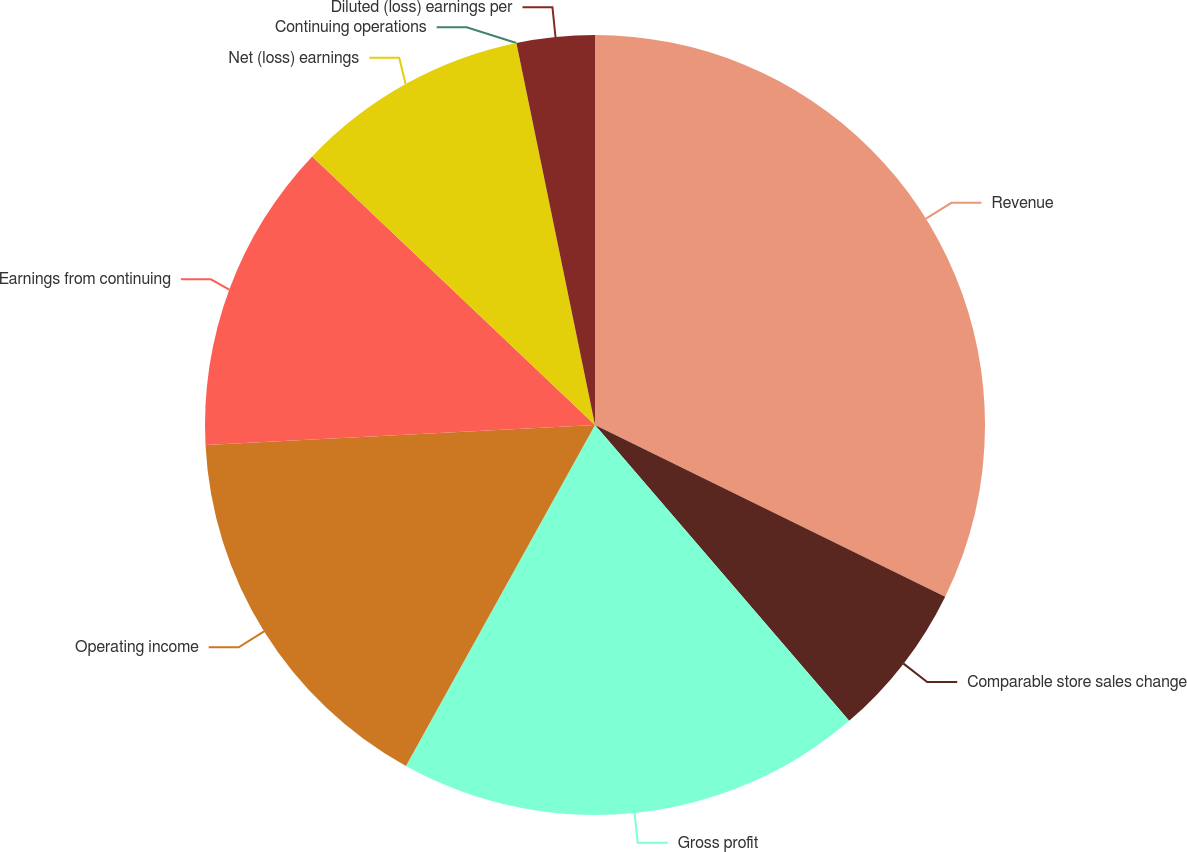Convert chart. <chart><loc_0><loc_0><loc_500><loc_500><pie_chart><fcel>Revenue<fcel>Comparable store sales change<fcel>Gross profit<fcel>Operating income<fcel>Earnings from continuing<fcel>Net (loss) earnings<fcel>Continuing operations<fcel>Diluted (loss) earnings per<nl><fcel>32.25%<fcel>6.45%<fcel>19.35%<fcel>16.13%<fcel>12.9%<fcel>9.68%<fcel>0.0%<fcel>3.23%<nl></chart> 